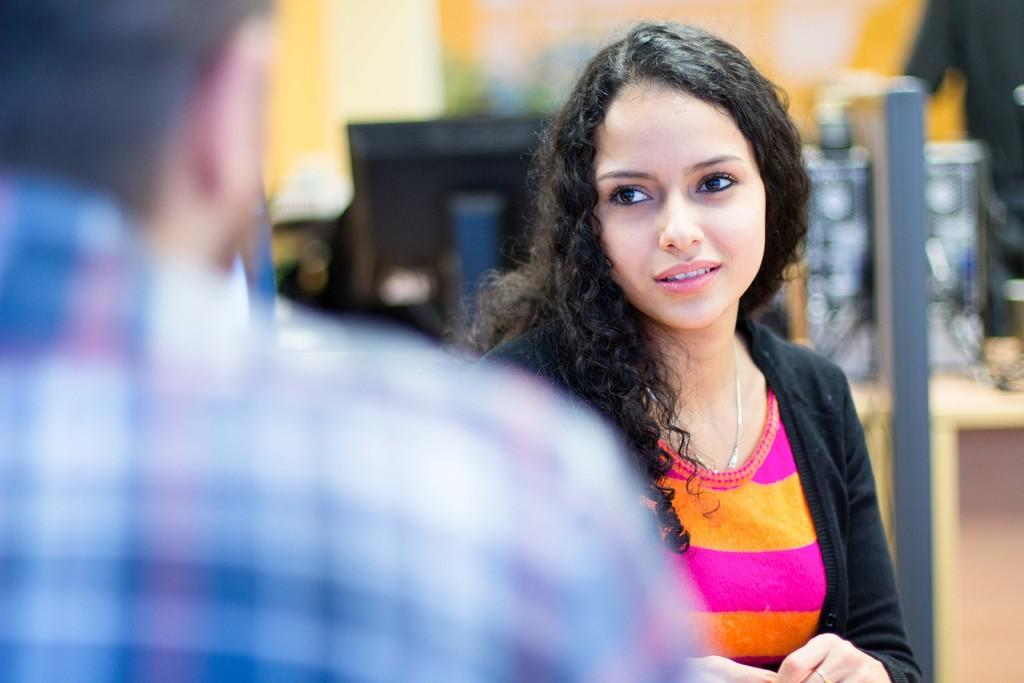Who is the main subject in the image? There is a lady in the center of the image. Can you describe the person to the left side of the image? There is a person to the left side of the image. What can be seen in the background of the image? There is a monitor in the background of the image. What type of volcanic activity can be seen in the image? There is no volcanic activity present in the image. What is the ground like in the image? The ground is not visible in the image, as it focuses on the lady, the person to the left, and the monitor in the background. 